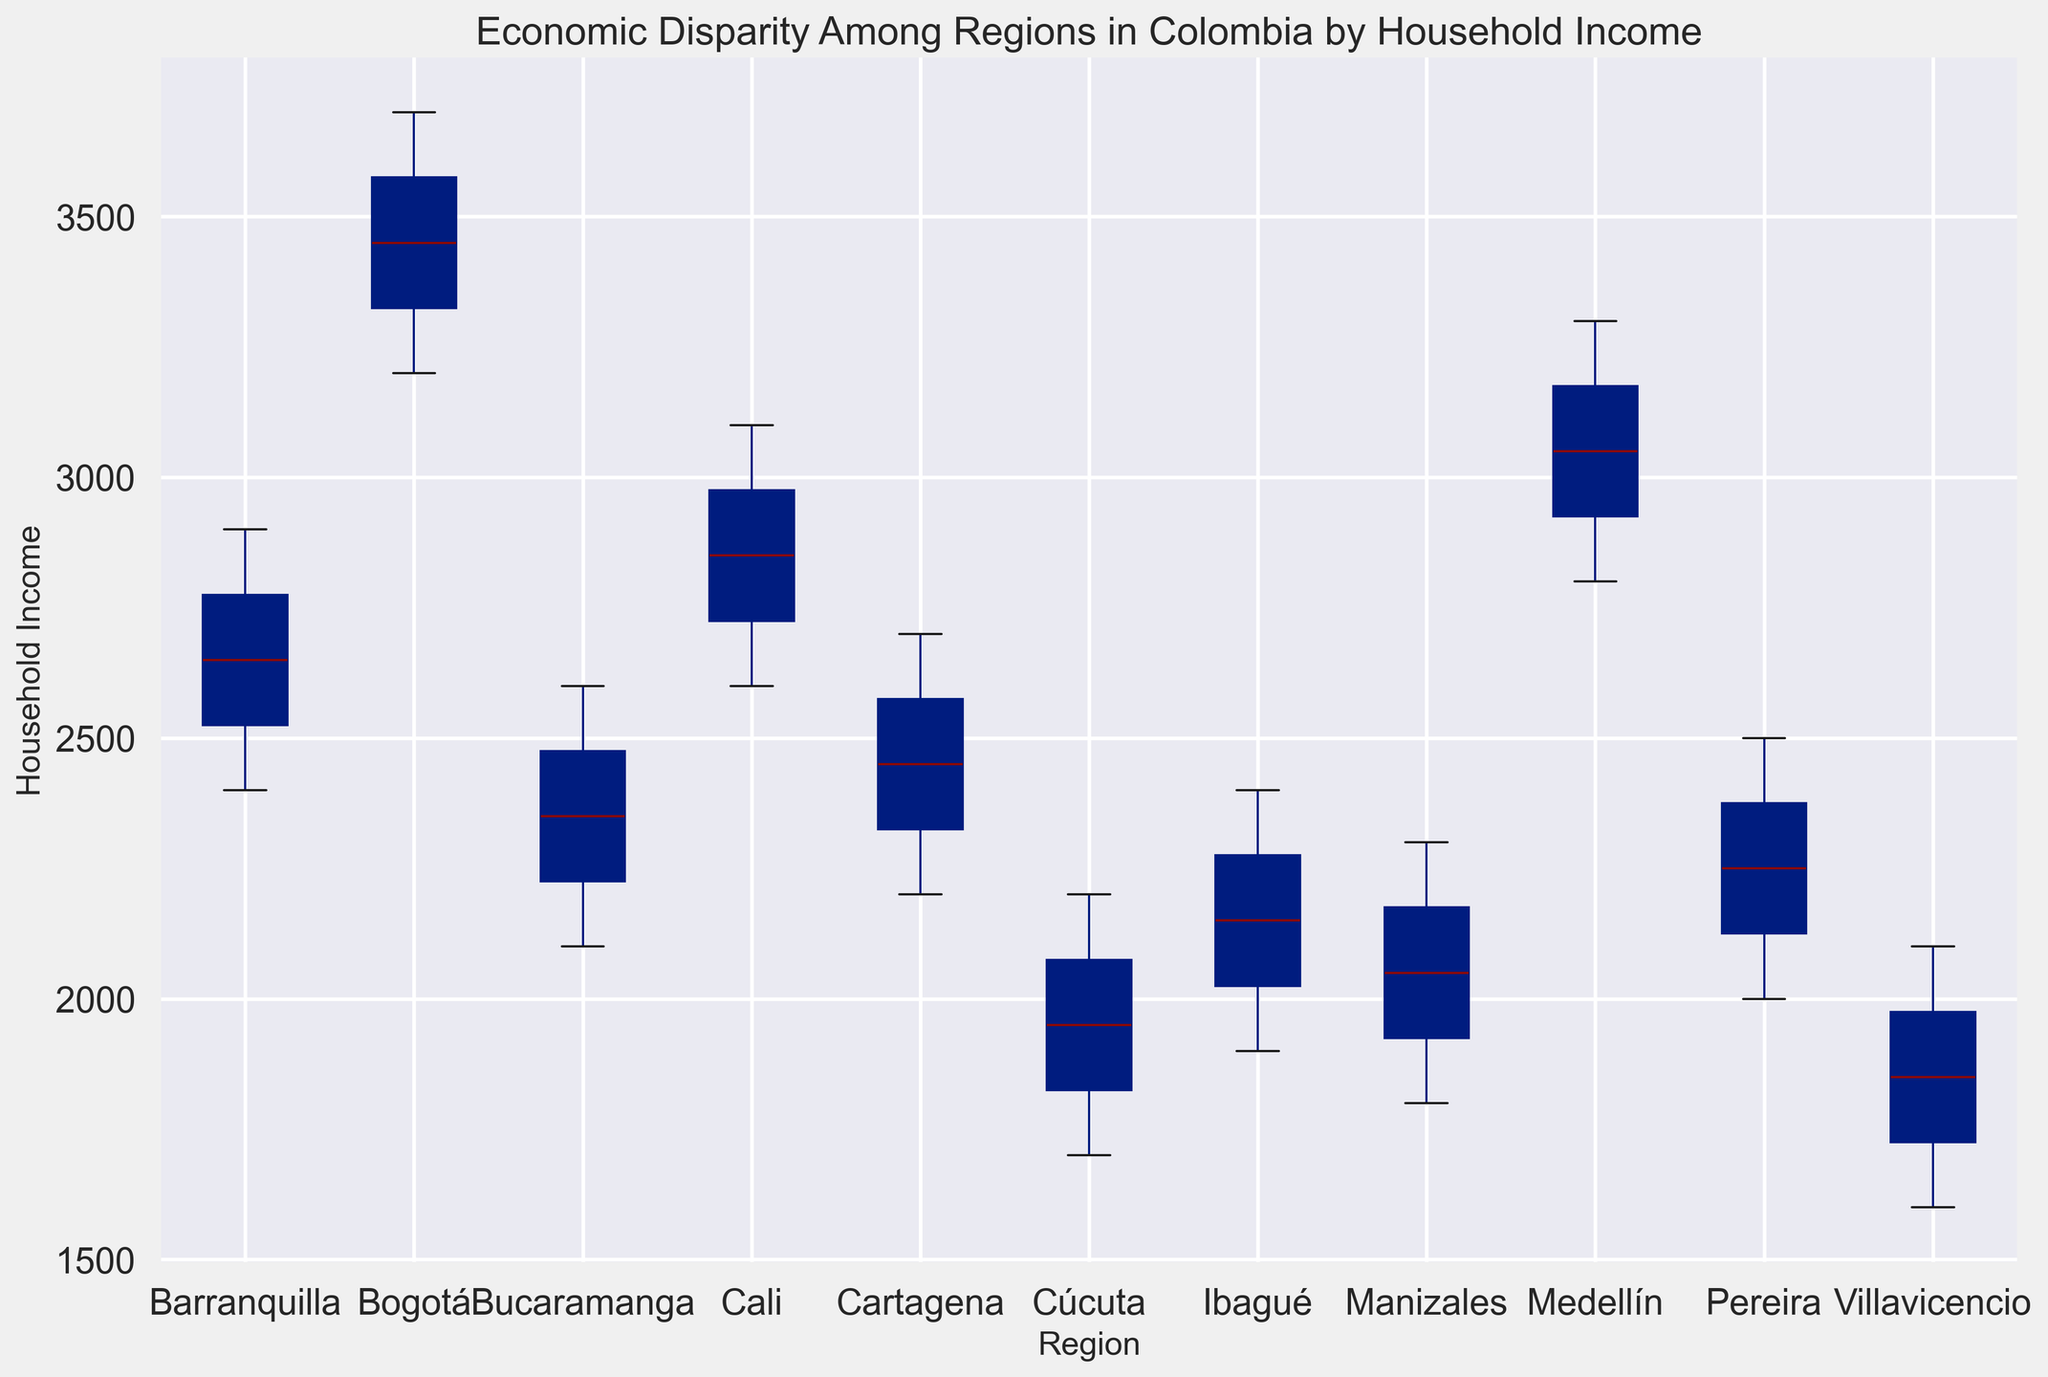Which region has the highest median household income? By looking at the figure, identify the central line in each boxplot. The region with the highest median value has the highest median household income.
Answer: Bogotá Which region shows the largest interquartile range (IQR) in household income? Locate the box (which represents the IQR) for each region. Compare the lengths and identify which box is the longest.
Answer: Bogotá Compare the median household incomes of Medellín and Cali. Which one is higher? Find the central line in the boxes for both Medellín and Cali. The higher line represents the region with the higher median household income.
Answer: Medellín How does the range of incomes in Barranquilla compare to that in Bucaramanga? Observe the whiskers of the box plots representing the range of incomes. Compare the lengths of these whiskers for Barranquilla and Bucaramanga to see which one is longer.
Answer: Barranquilla has a larger range What is the position of Ibagué in terms of household income compared to Bogotá? Observe the positions of both boxes. The median line in Ibagué's boxplot will be significantly lower than that in Bogotá, indicating a lower household income.
Answer: Lower Which regions have overlapping interquartile ranges? Check if the boxes overlap on the horizontal scale. Identify the regions whose boxes intersect vertically.
Answer: Medellín and Cali, Barranquilla and Cartagena Estimate the difference in median household income between Cartagena and Bogotá. Locate the central lines of the boxes for both regions. Measure the vertical distance between these lines to estimate the difference.
Answer: Approximately 1000 units Which region has the smallest variation in household income? Look for the region with the shortest boxplot including both the IQR and the whiskers. This region shows the least variation.
Answer: Manizales Do Villavicencio and Cúcuta have similar household income distributions? Inspect the position and length of the boxes and whiskers for both regions. Compare their similarities in median, IQR, and range.
Answer: Yes, they are similar 